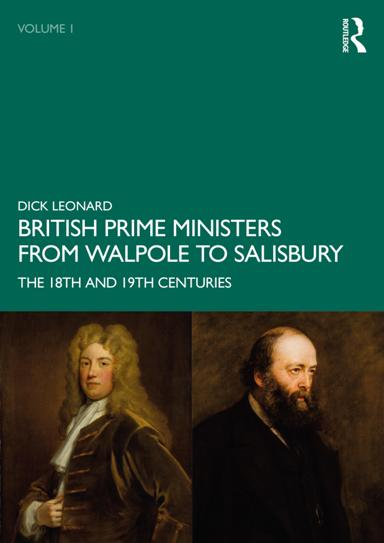What book is mentioned in the image? The book mentioned in the image is "British Prime Ministers From Walpole to Salisbury: The 18th and 19th Centuries" by R. Dick Leonard. What time periods does the book cover? The book covers the 18th and 19th centuries. 